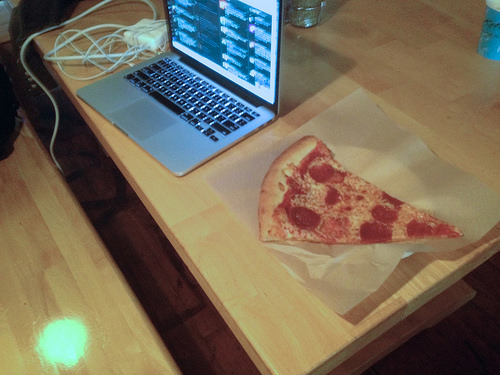<image>
Can you confirm if the pizza slice is in front of the computer? No. The pizza slice is not in front of the computer. The spatial positioning shows a different relationship between these objects. Is there a lap top above the table? No. The lap top is not positioned above the table. The vertical arrangement shows a different relationship. 